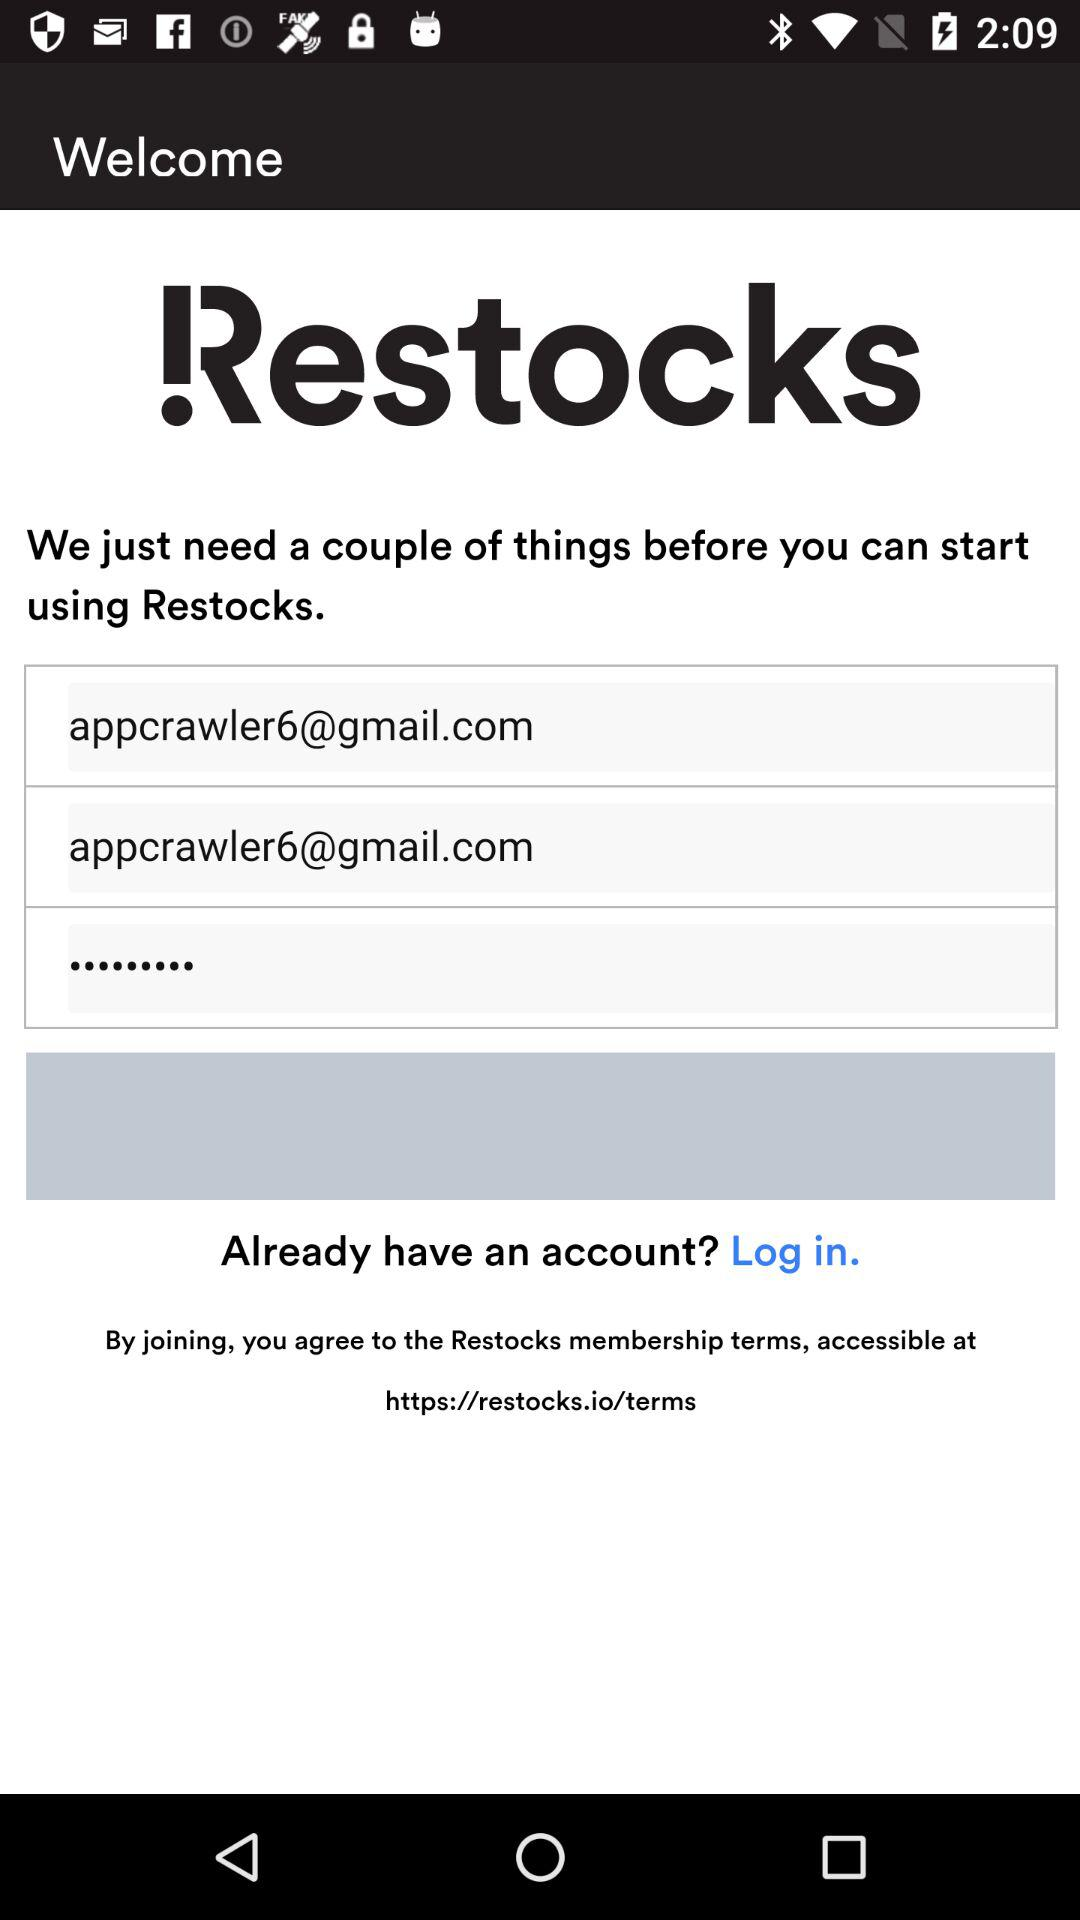What is the application name? The application name is "Restocks". 